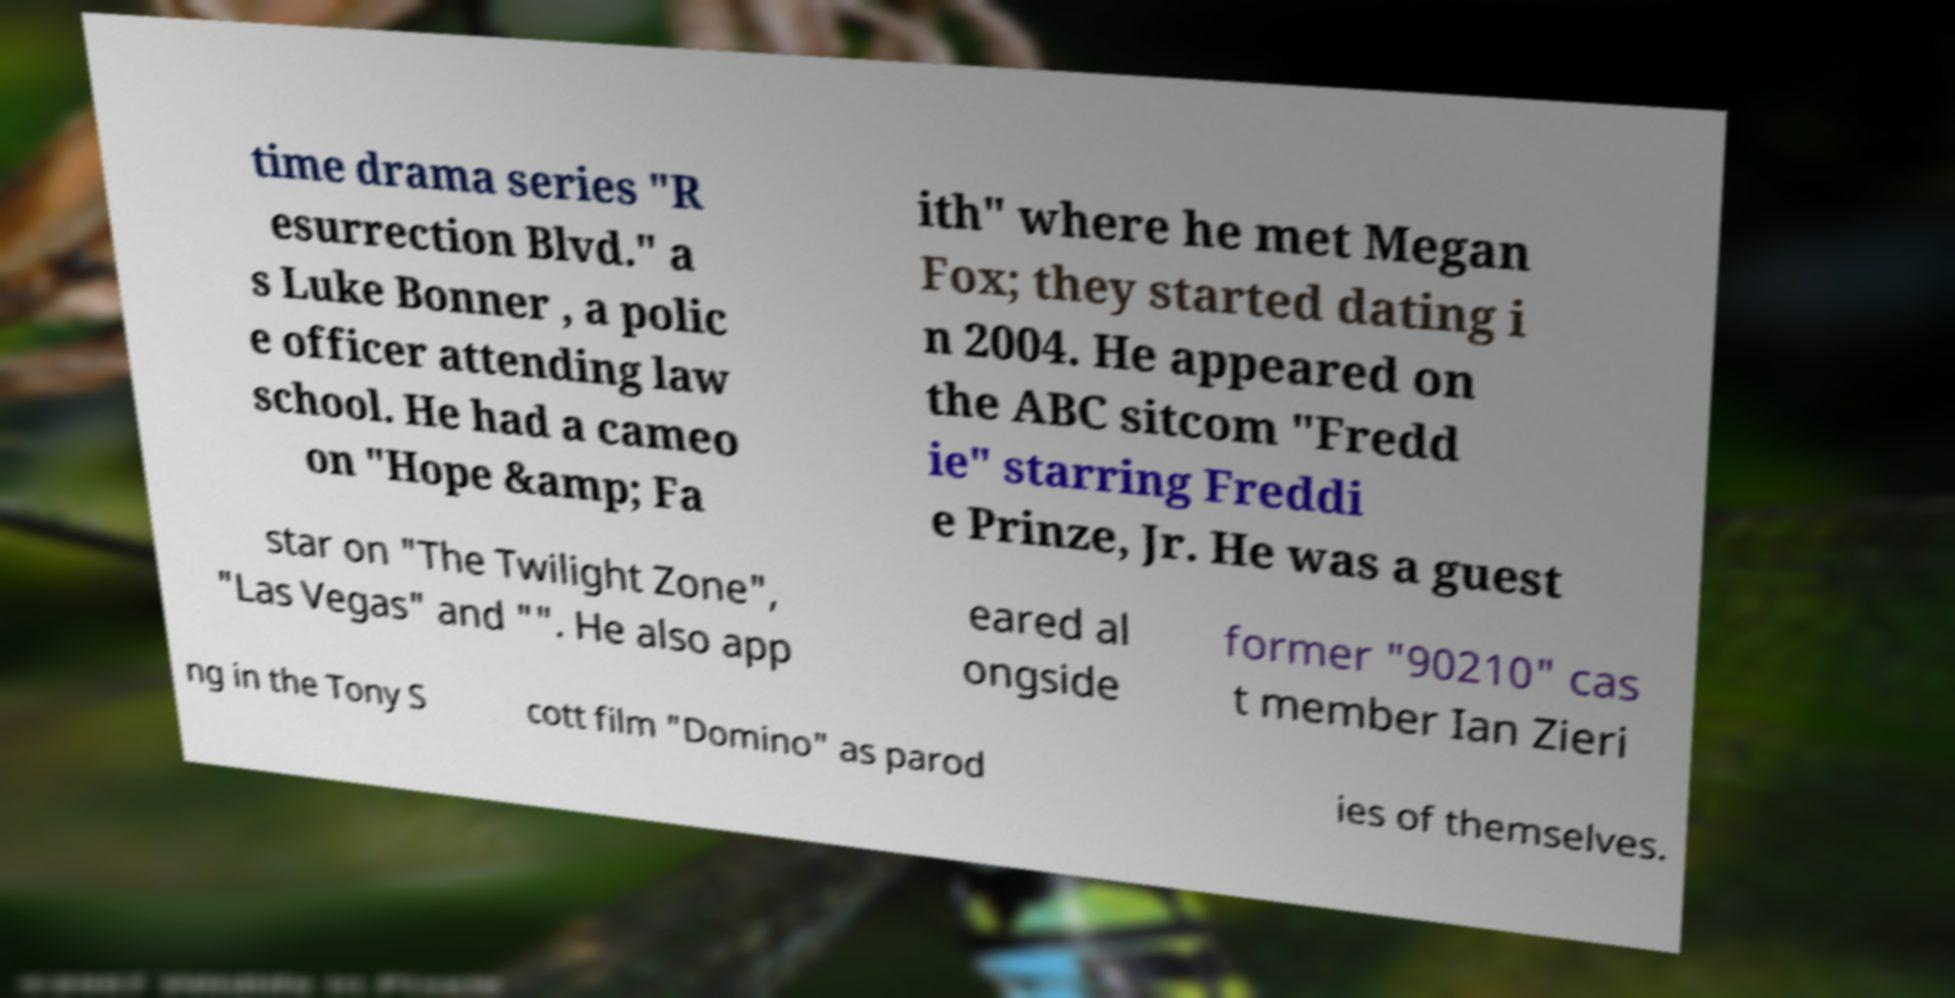Please identify and transcribe the text found in this image. time drama series "R esurrection Blvd." a s Luke Bonner , a polic e officer attending law school. He had a cameo on "Hope &amp; Fa ith" where he met Megan Fox; they started dating i n 2004. He appeared on the ABC sitcom "Fredd ie" starring Freddi e Prinze, Jr. He was a guest star on "The Twilight Zone", "Las Vegas" and "". He also app eared al ongside former "90210" cas t member Ian Zieri ng in the Tony S cott film "Domino" as parod ies of themselves. 